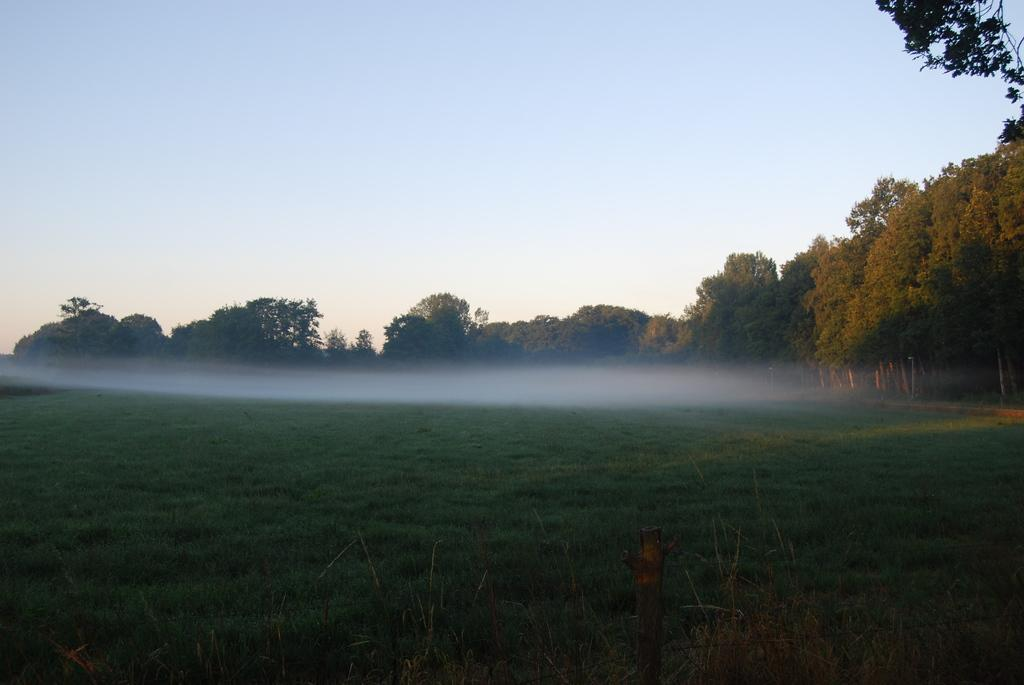What type of landscape is depicted in the image? There is a grassland in the image. Are there any other natural elements present in the grassland? Yes, there are trees in the grassland. What is visible at the top of the image? The sky is visible at the top of the image. Where is the bun hiding in the image? There is no bun present in the image. Can you see a kitty playing among the trees in the grassland? There is no kitty present in the image; only trees are visible in the grassland. 